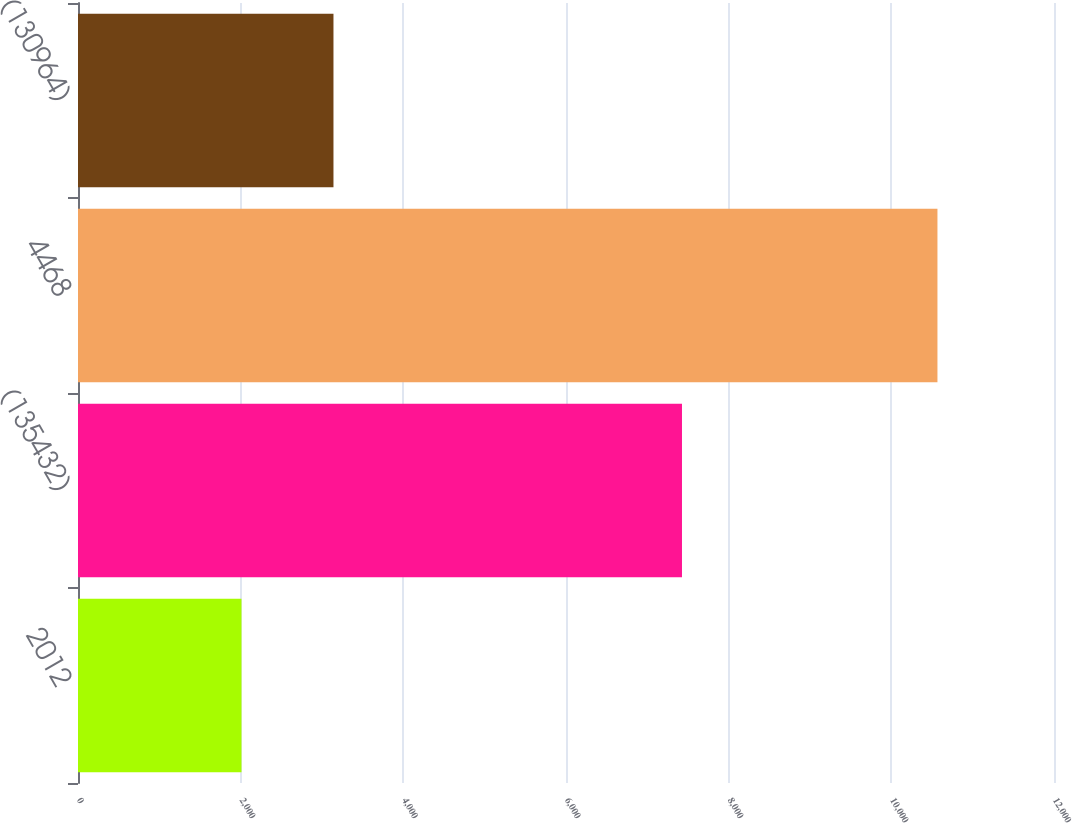Convert chart to OTSL. <chart><loc_0><loc_0><loc_500><loc_500><bar_chart><fcel>2012<fcel>(135432)<fcel>4468<fcel>(130964)<nl><fcel>2010<fcel>7426<fcel>10567<fcel>3141<nl></chart> 